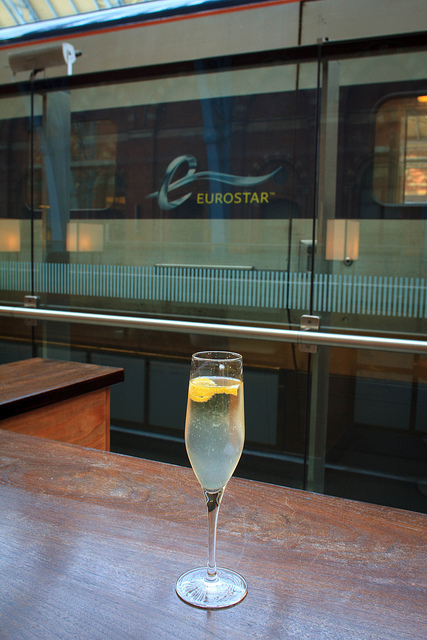Read and extract the text from this image. EUROSTAR EUROSTAR 